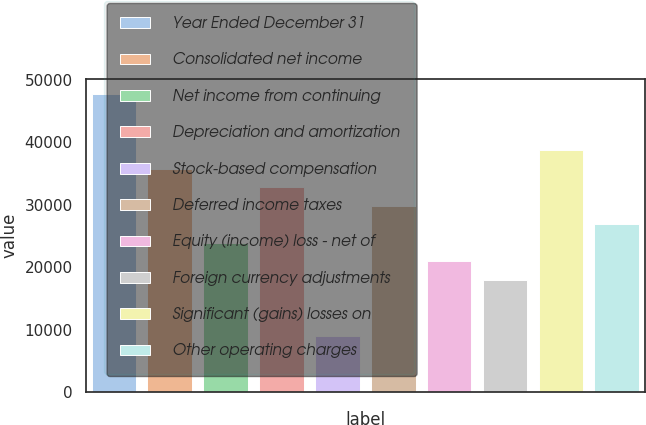Convert chart to OTSL. <chart><loc_0><loc_0><loc_500><loc_500><bar_chart><fcel>Year Ended December 31<fcel>Consolidated net income<fcel>Net income from continuing<fcel>Depreciation and amortization<fcel>Stock-based compensation<fcel>Deferred income taxes<fcel>Equity (income) loss - net of<fcel>Foreign currency adjustments<fcel>Significant (gains) losses on<fcel>Other operating charges<nl><fcel>47716.6<fcel>35810.2<fcel>23903.8<fcel>32833.6<fcel>9020.8<fcel>29857<fcel>20927.2<fcel>17950.6<fcel>38786.8<fcel>26880.4<nl></chart> 